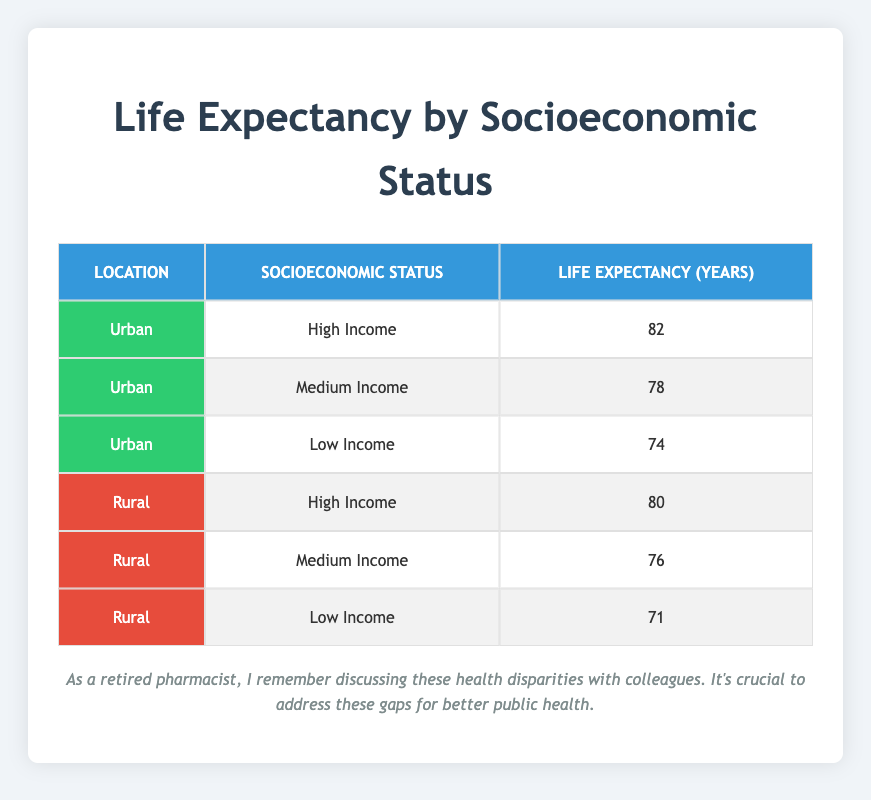What is the life expectancy for people with high income in urban areas? The table shows that the life expectancy for individuals with high income in urban areas is 82 years.
Answer: 82 What is the life expectancy for people with low income in rural areas? According to the table, people with low income in rural areas have a life expectancy of 71 years.
Answer: 71 Is the life expectancy for medium income individuals in urban areas higher than in rural areas? In urban areas, the life expectancy for medium income is 78 years, while in rural areas it is 76 years. Since 78 is greater than 76, the statement is true.
Answer: Yes What is the difference in life expectancy between high income individuals in urban and rural areas? The life expectancy in urban areas for high income is 82 years and in rural areas it is 80 years. The difference is 82 - 80 = 2 years.
Answer: 2 What is the average life expectancy for all income levels in rural areas? The life expectancies for all income levels in rural areas are 80, 76, and 71 years. Adding these gives 80 + 76 + 71 = 227, and dividing by 3 (the number of groups) gives an average of 227 / 3 ≈ 75.67 years.
Answer: 75.67 Is the life expectancy for low income individuals in urban areas greater than that in rural areas? In urban areas, the life expectancy for low income is 74 years, and in rural areas, it is 71 years. Since 74 is greater than 71, the statement is true.
Answer: Yes What is the highest life expectancy recorded in the table? The highest life expectancy is found for urban areas with high income, which is 82 years.
Answer: 82 What is the life expectancy for people with medium income in urban areas? The table indicates that people with medium income in urban areas have a life expectancy of 78 years.
Answer: 78 What is the lowest life expectancy among all groups in the table? The lowest life expectancy recorded is for low income individuals in rural areas, which is 71 years.
Answer: 71 What is the total life expectancy for high income individuals across both urban and rural areas? The life expectancy for high income individuals in urban areas is 82 years and in rural areas is 80 years. Adding these gives 82 + 80 = 162 years.
Answer: 162 